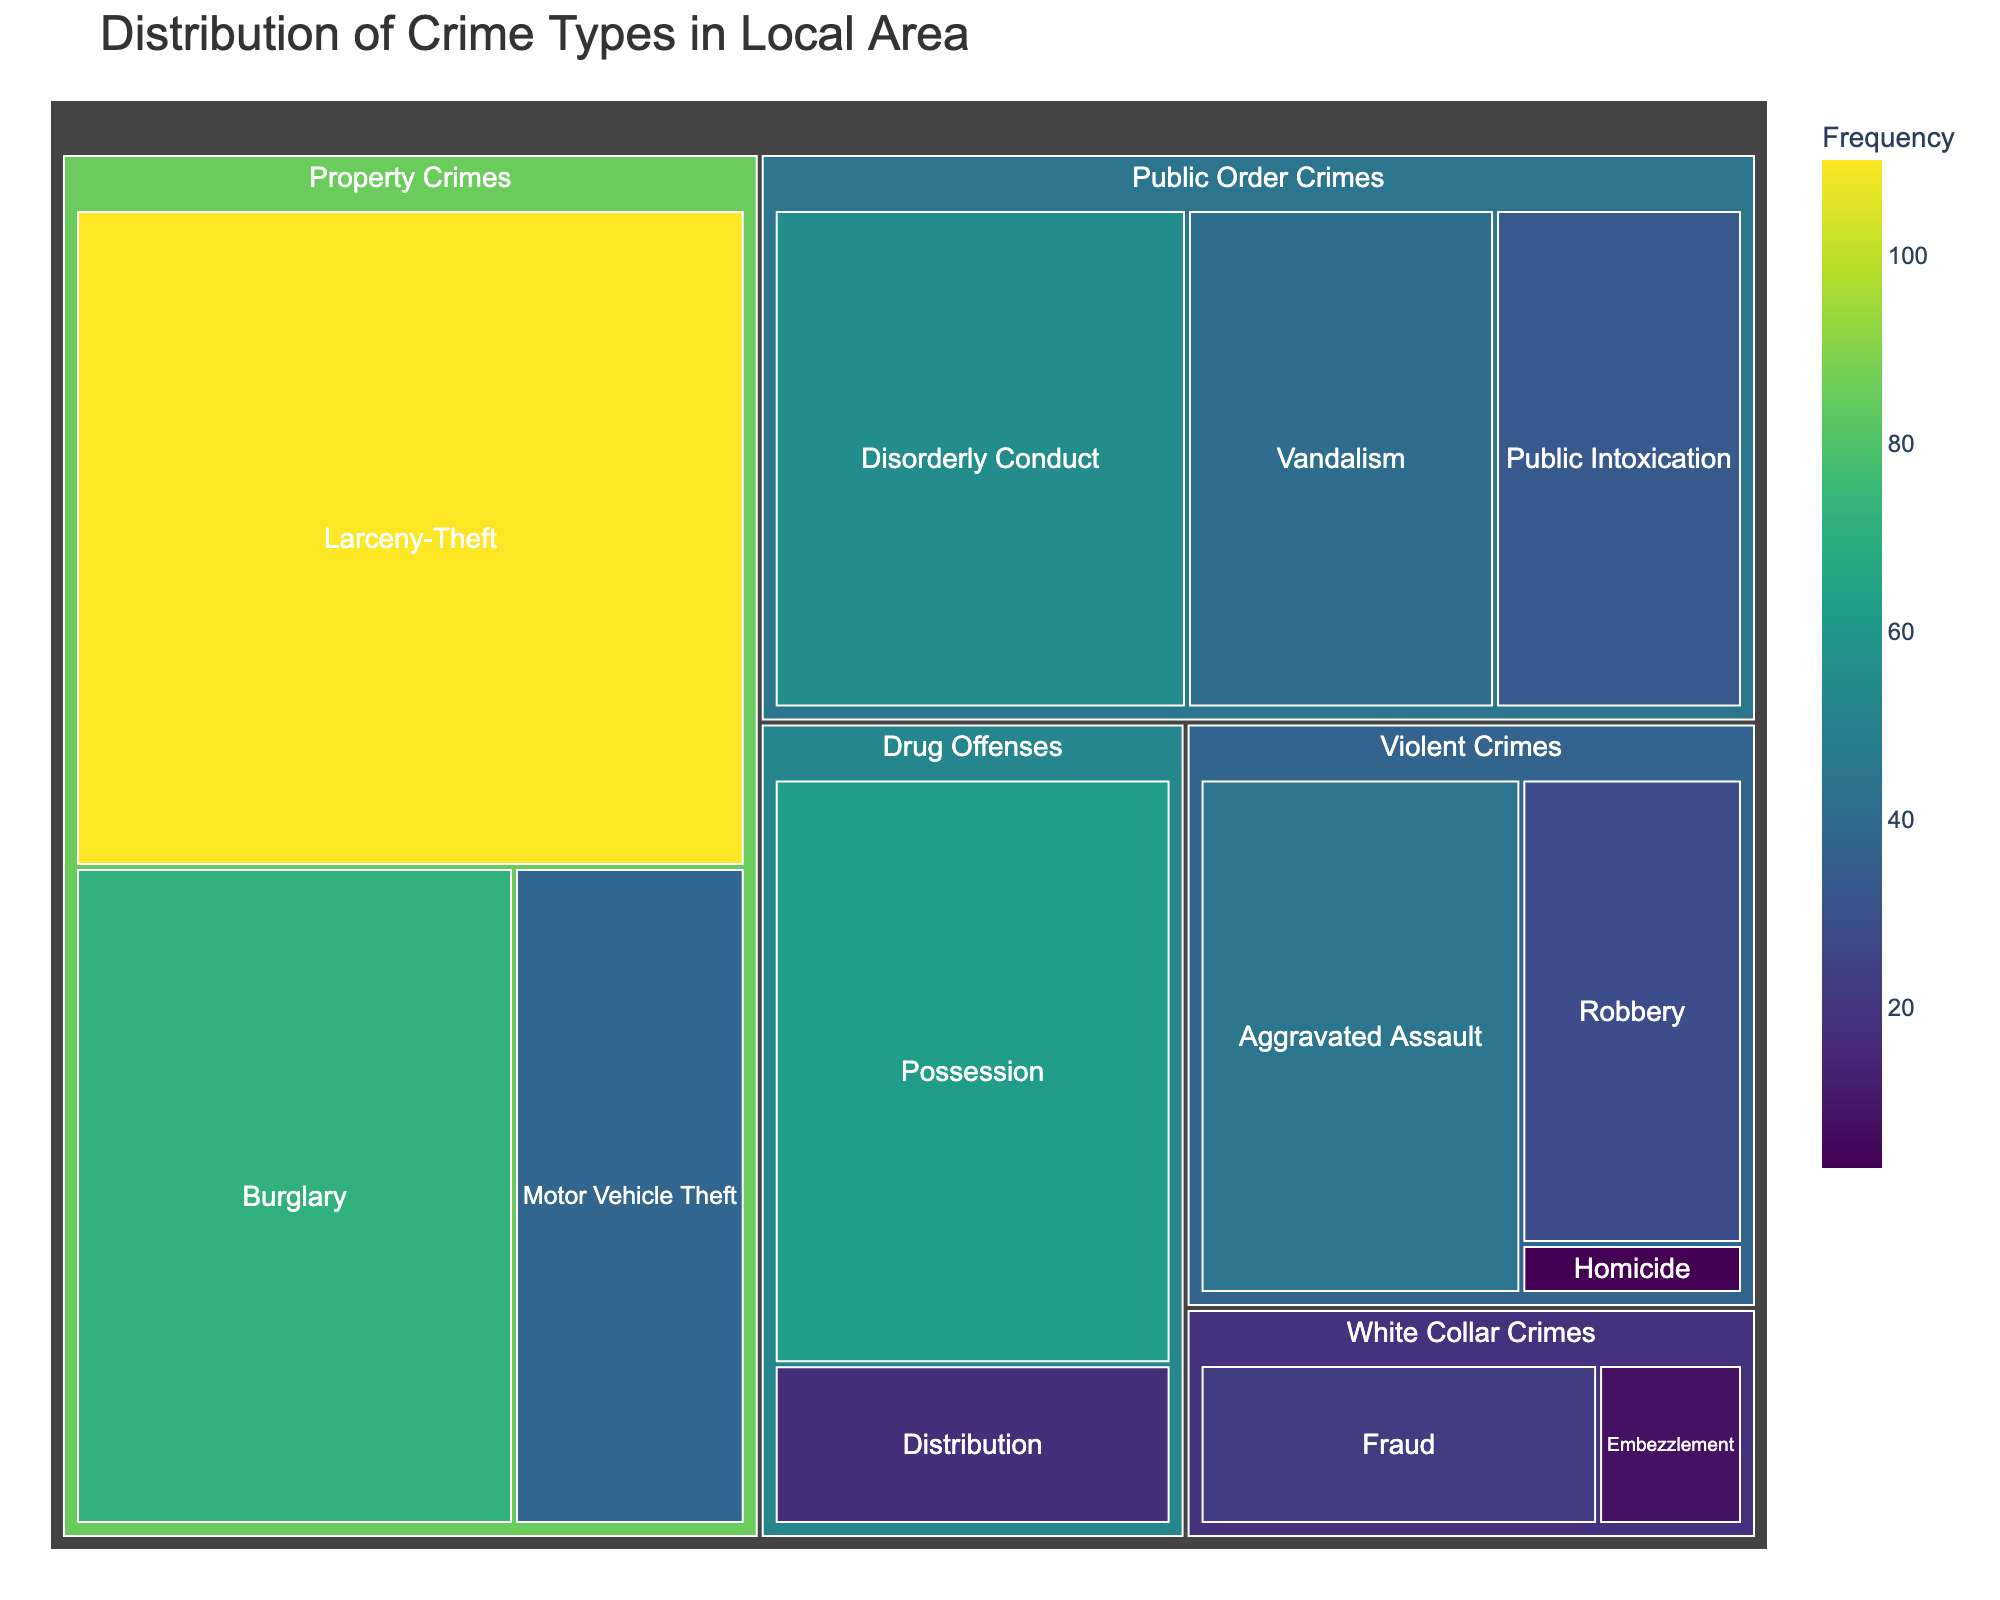What is the most common type of crime? To determine the most common type of crime, look for the subcategory with the largest area in the treemap. "Larceny-Theft" has the largest area, indicating it has the highest frequency.
Answer: Larceny-Theft How many types of Violent Crimes are shown? Look for the categories under "Violent Crimes" and count the distinct subcategories. They are "Aggravated Assault," "Robbery," and "Homicide."
Answer: 3 Which category has the least frequent crime, and what is it? Identify the smallest area in the treemap. The smallest area corresponds to "Homicide" under "Violent Crimes" with a frequency of 3.
Answer: Violent Crimes, Homicide What is the combined frequency of all Property Crimes? Sum up the values of all subcategories under the "Property Crimes" category: Burglary (72), Larceny-Theft (110), and Motor Vehicle Theft (38). The combined frequency is 72 + 110 + 38 = 220.
Answer: 220 Which is more frequent: Public Intoxication or Disorderly Conduct? Compare the areas representing "Public Intoxication" and "Disorderly Conduct" under "Public Order Crimes." Disorderly Conduct has a larger area, representing a higher frequency of 55 compared to Public Intoxication's 33.
Answer: Disorderly Conduct Compare the frequency of Drug Offenses to White Collar Crimes. Which is higher? Sum the values of subcategories under "Drug Offenses" and "White Collar Crimes." Drug Offenses include Possession (62) and Distribution (17) for a total of 79. White Collar Crimes include Fraud (22) and Embezzlement (8) for a total of 30. 79 is greater than 30.
Answer: Drug Offenses Which category has the highest variability in crime frequencies? Assess variability by checking the range in frequencies of subcategories in each category. "Drug Offenses" has a broader range (62 for Possession, 17 for Distribution) compared to other categories, indicating higher variability.
Answer: Drug Offenses What is the second most frequent crime type after Larceny-Theft? Identify the second largest area in the treemap after Larceny-Theft. "Burglary" under "Property Crimes" has the second largest area, indicating it is the second most frequent.
Answer: Burglary 